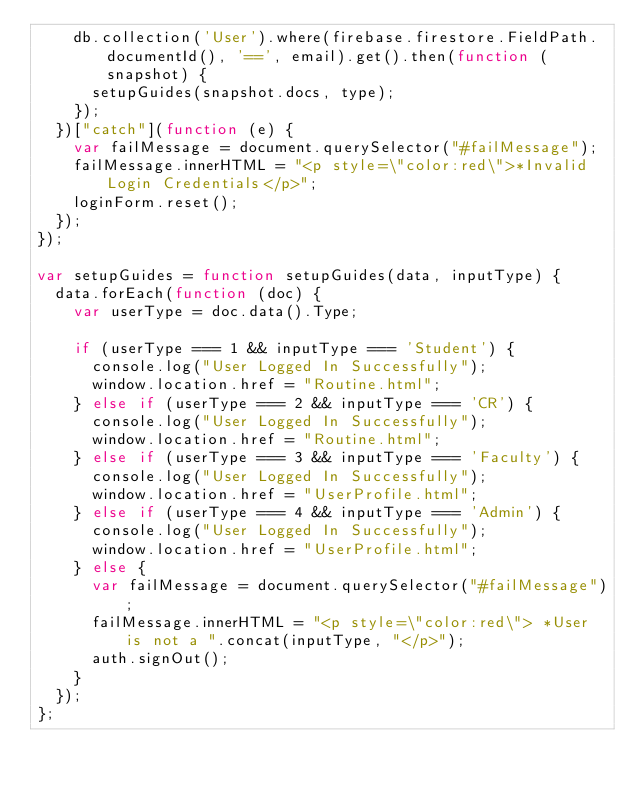<code> <loc_0><loc_0><loc_500><loc_500><_JavaScript_>    db.collection('User').where(firebase.firestore.FieldPath.documentId(), '==', email).get().then(function (snapshot) {
      setupGuides(snapshot.docs, type);
    });
  })["catch"](function (e) {
    var failMessage = document.querySelector("#failMessage");
    failMessage.innerHTML = "<p style=\"color:red\">*Invalid Login Credentials</p>";
    loginForm.reset();
  });
});

var setupGuides = function setupGuides(data, inputType) {
  data.forEach(function (doc) {
    var userType = doc.data().Type;

    if (userType === 1 && inputType === 'Student') {
      console.log("User Logged In Successfully");
      window.location.href = "Routine.html";
    } else if (userType === 2 && inputType === 'CR') {
      console.log("User Logged In Successfully");
      window.location.href = "Routine.html";
    } else if (userType === 3 && inputType === 'Faculty') {
      console.log("User Logged In Successfully");
      window.location.href = "UserProfile.html";
    } else if (userType === 4 && inputType === 'Admin') {
      console.log("User Logged In Successfully");
      window.location.href = "UserProfile.html";
    } else {
      var failMessage = document.querySelector("#failMessage");
      failMessage.innerHTML = "<p style=\"color:red\"> *User is not a ".concat(inputType, "</p>");
      auth.signOut();
    }
  });
};</code> 